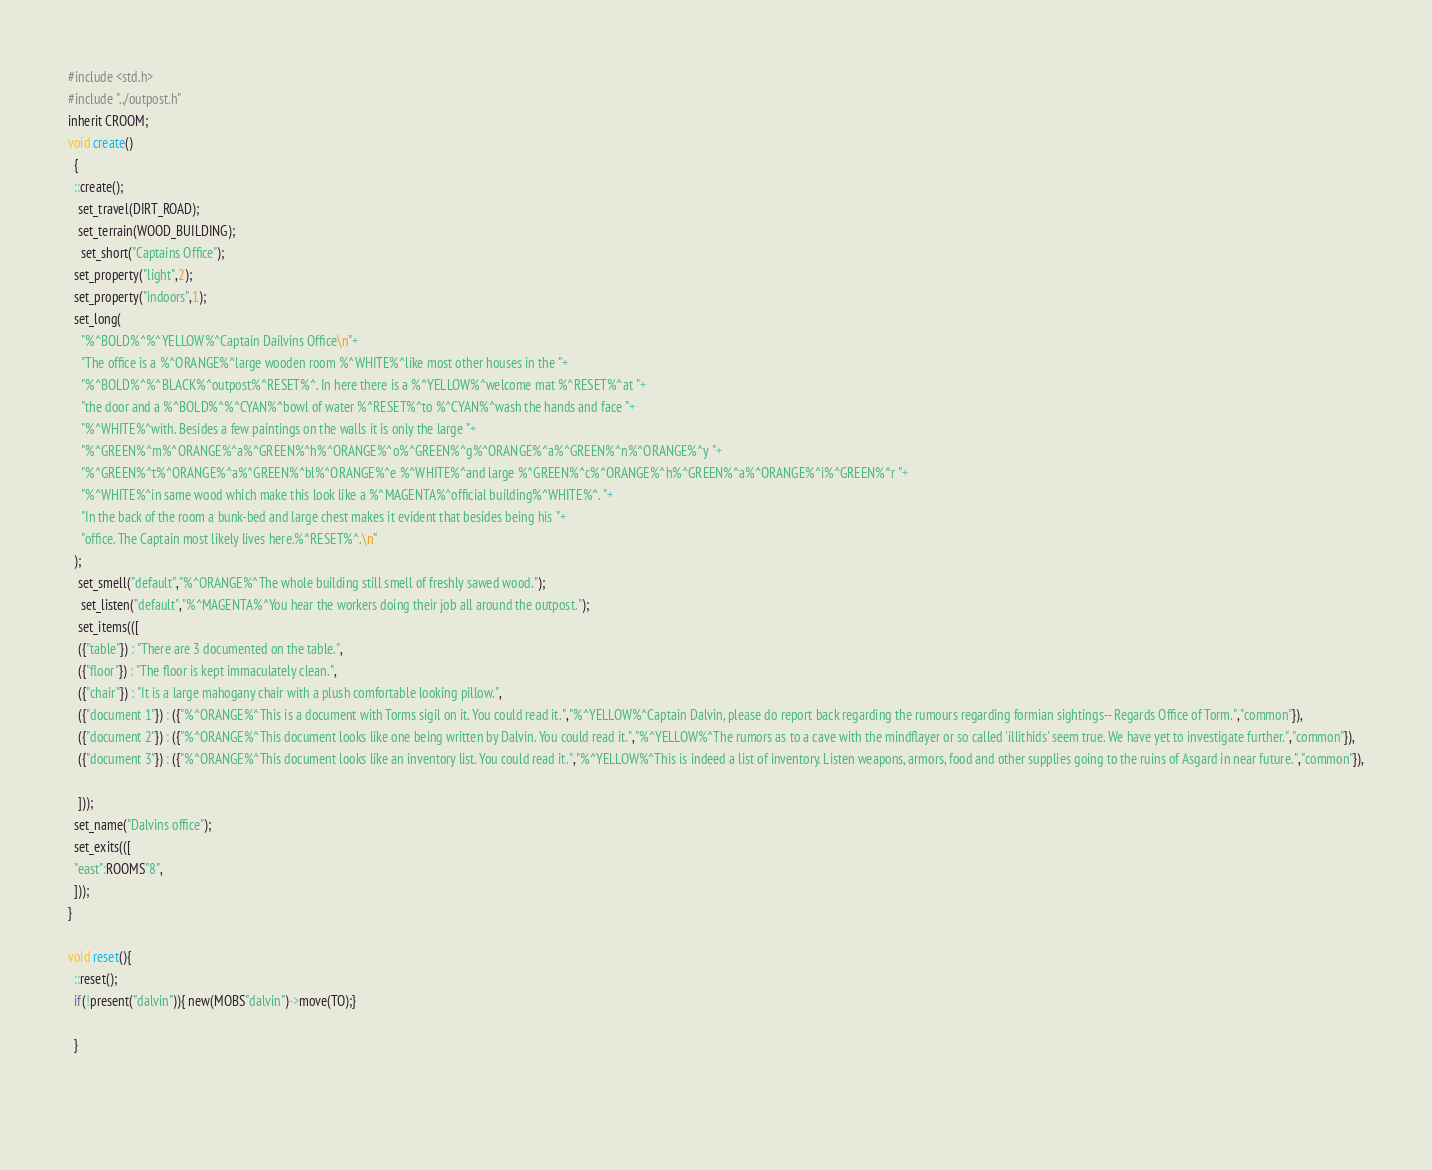Convert code to text. <code><loc_0><loc_0><loc_500><loc_500><_C_>#include <std.h>
#include "../outpost.h"
inherit CROOM;
void create()
  {
  ::create();
   set_travel(DIRT_ROAD);
   set_terrain(WOOD_BUILDING);
    set_short("Captains Office");
  set_property("light",2);
  set_property("indoors",1);
  set_long(
    "%^BOLD%^%^YELLOW%^Captain Dailvins Office\n"+
    "The office is a %^ORANGE%^large wooden room %^WHITE%^like most other houses in the "+
	"%^BOLD%^%^BLACK%^outpost%^RESET%^. In here there is a %^YELLOW%^welcome mat %^RESET%^at "+
	"the door and a %^BOLD%^%^CYAN%^bowl of water %^RESET%^to %^CYAN%^wash the hands and face "+
	"%^WHITE%^with. Besides a few paintings on the walls it is only the large "+
	"%^GREEN%^m%^ORANGE%^a%^GREEN%^h%^ORANGE%^o%^GREEN%^g%^ORANGE%^a%^GREEN%^n%^ORANGE%^y "+
	"%^GREEN%^t%^ORANGE%^a%^GREEN%^bl%^ORANGE%^e %^WHITE%^and large %^GREEN%^c%^ORANGE%^h%^GREEN%^a%^ORANGE%^i%^GREEN%^r "+
	"%^WHITE%^in same wood which make this look like a %^MAGENTA%^official building%^WHITE%^. "+
	"In the back of the room a bunk-bed and large chest makes it evident that besides being his "+
	"office. The Captain most likely lives here.%^RESET%^.\n"
  );
   set_smell("default","%^ORANGE%^The whole building still smell of freshly sawed wood.");
    set_listen("default","%^MAGENTA%^You hear the workers doing their job all around the outpost.");
   set_items(([
   ({"table"}) : "There are 3 documented on the table.",
   ({"floor"}) : "The floor is kept immaculately clean.",
   ({"chair"}) : "It is a large mahogany chair with a plush comfortable looking pillow.",
   ({"document 1"}) : ({"%^ORANGE%^This is a document with Torms sigil on it. You could read it.","%^YELLOW%^Captain Dalvin, please do report back regarding the rumours regarding formian sightings-- Regards Office of Torm.","common"}),
   ({"document 2"}) : ({"%^ORANGE%^This document looks like one being written by Dalvin. You could read it.","%^YELLOW%^The rumors as to a cave with the mindflayer or so called 'illithids' seem true. We have yet to investigate further.","common"}),
   ({"document 3"}) : ({"%^ORANGE%^This document looks like an inventory list. You could read it.","%^YELLOW%^This is indeed a list of inventory. Listen weapons, armors, food and other supplies going to the ruins of Asgard in near future.","common"}),
   
   ]));
  set_name("Dalvins office");
  set_exits(([
  "east":ROOMS"8",
  ]));
}

void reset(){
  ::reset();
  if(!present("dalvin")){ new(MOBS"dalvin")->move(TO);}
  
  }

  
</code> 